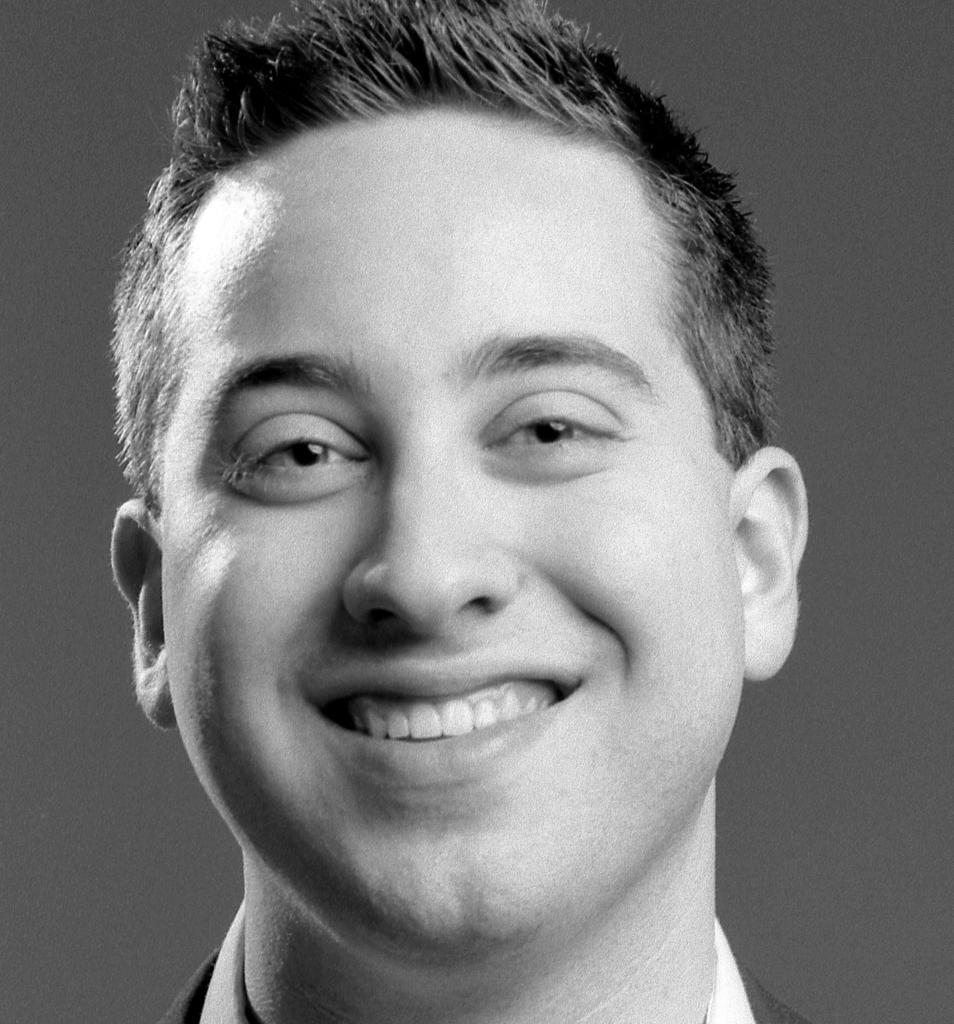In one or two sentences, can you explain what this image depicts? This is a black and white picture of a man, he is smiling. 